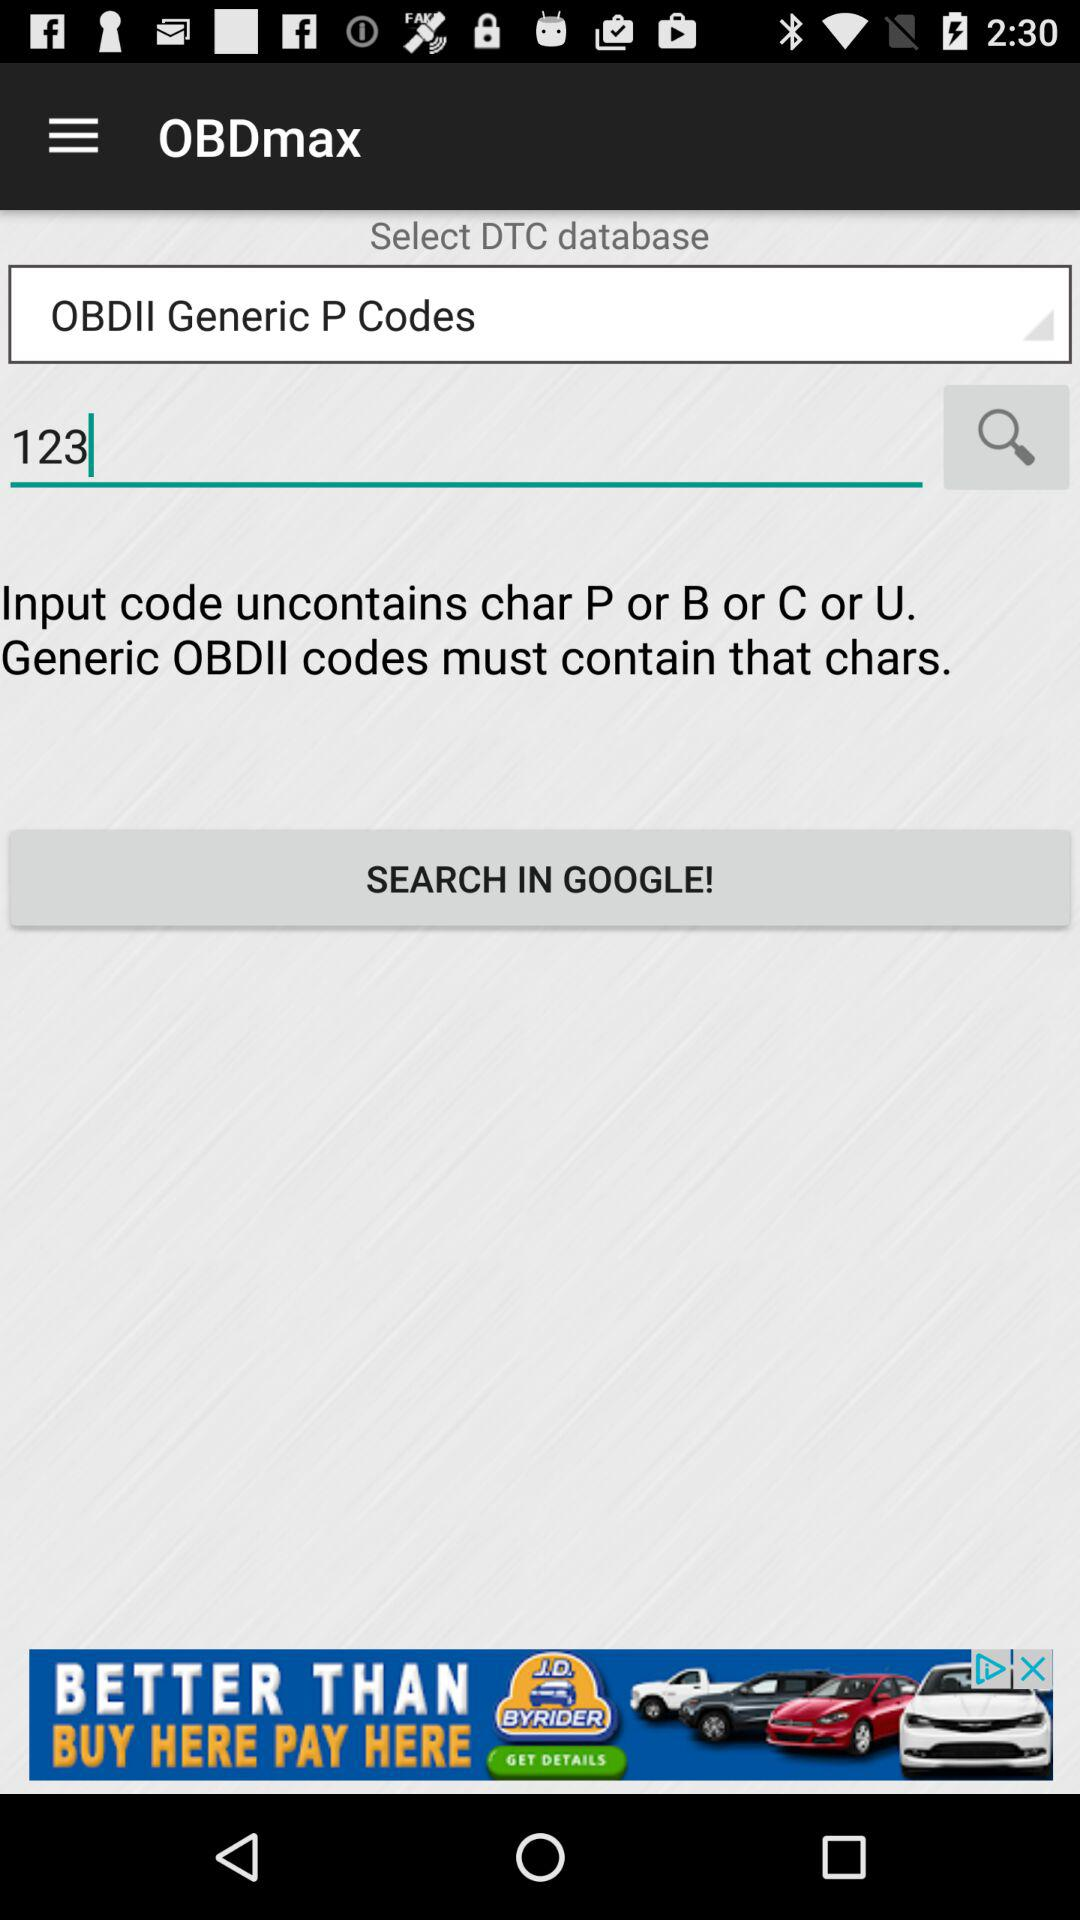Which set of characters do OBDII codes not contain? OBDII codes uncontains characters P or B or C or U. 